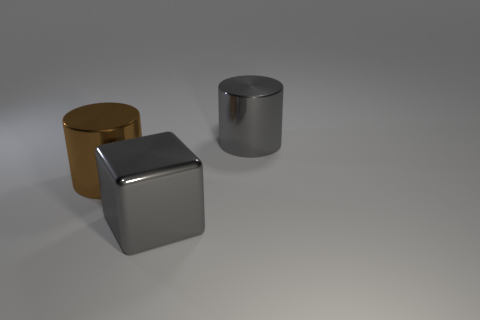How many other things are the same size as the brown metallic cylinder?
Your answer should be very brief. 2. How many large purple cylinders are there?
Provide a succinct answer. 0. Is the material of the gray object on the right side of the large gray metallic cube the same as the large object on the left side of the big metal cube?
Your answer should be compact. Yes. What number of gray objects are the same material as the brown cylinder?
Ensure brevity in your answer.  2. How many rubber objects are gray objects or gray cylinders?
Your answer should be very brief. 0. There is a gray object that is behind the large shiny block; is it the same shape as the big brown object that is left of the gray metallic cylinder?
Offer a very short reply. Yes. The big thing that is right of the large brown shiny cylinder and behind the big gray metallic block is what color?
Provide a short and direct response. Gray. There is a shiny object that is left of the metal block; is its size the same as the gray shiny object on the left side of the gray cylinder?
Offer a terse response. Yes. What number of cylinders have the same color as the big cube?
Your answer should be compact. 1. What number of large objects are green objects or metal blocks?
Provide a short and direct response. 1. 